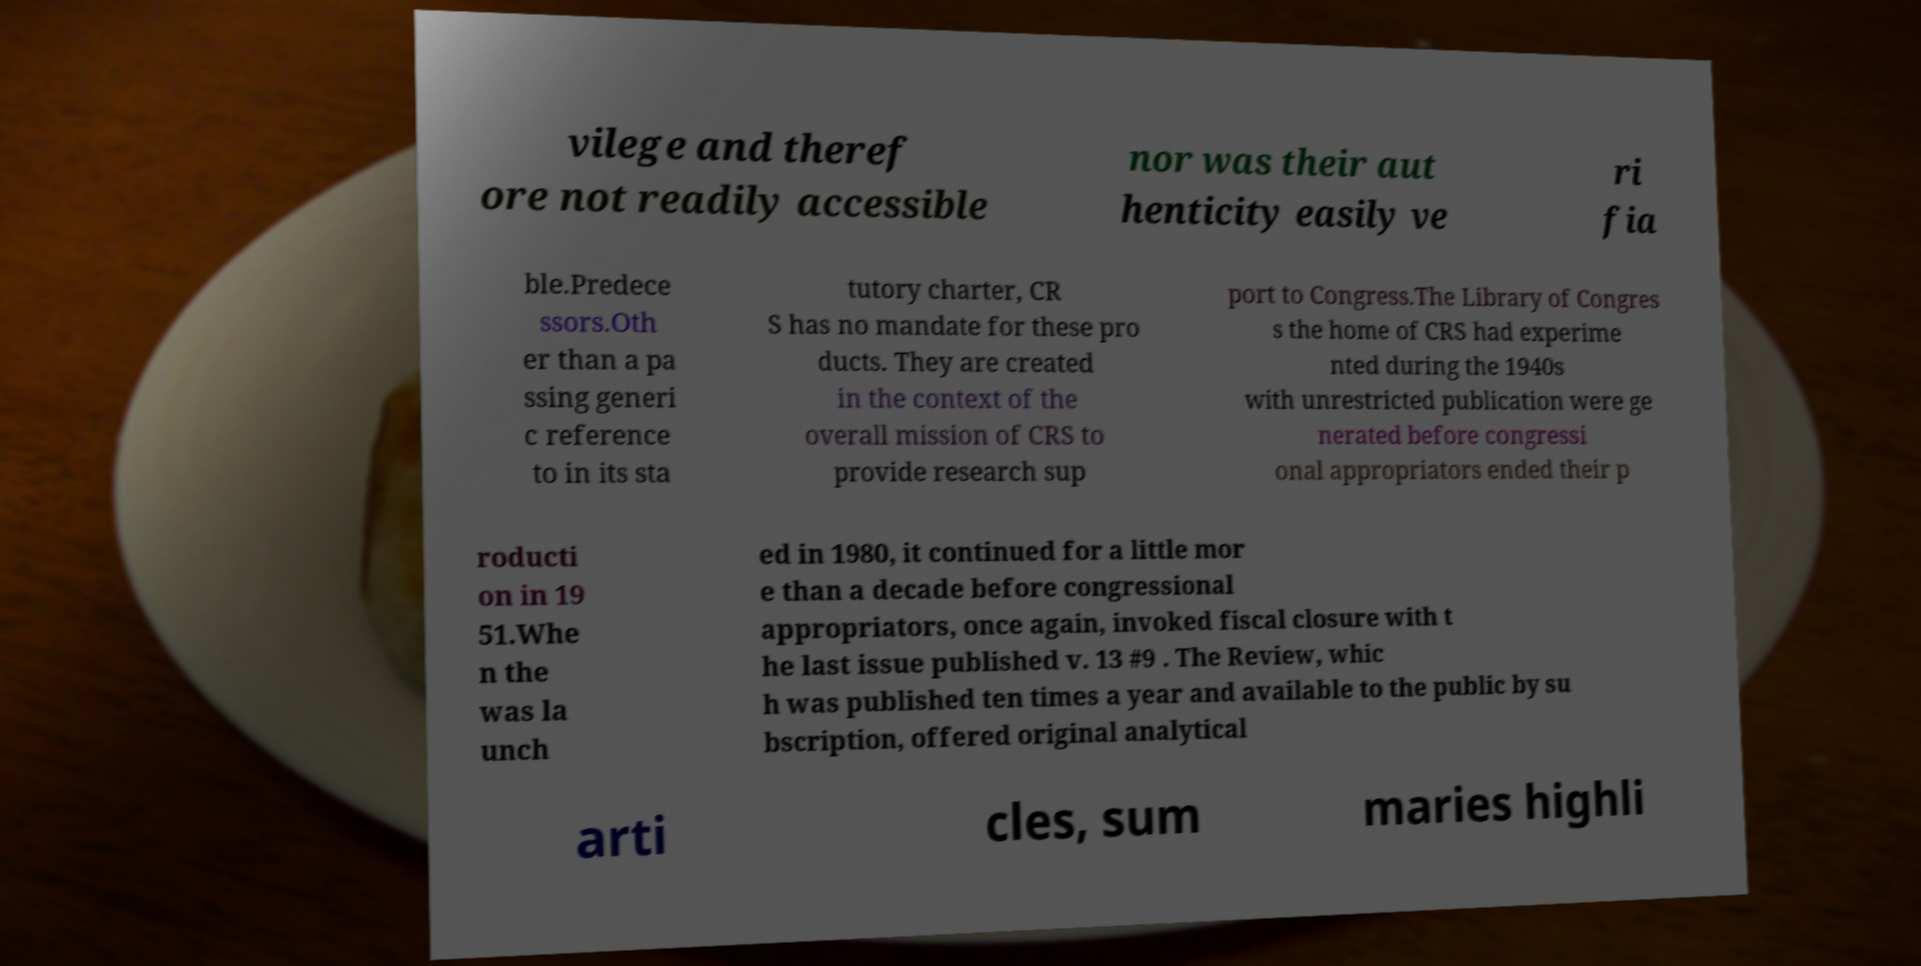What messages or text are displayed in this image? I need them in a readable, typed format. vilege and theref ore not readily accessible nor was their aut henticity easily ve ri fia ble.Predece ssors.Oth er than a pa ssing generi c reference to in its sta tutory charter, CR S has no mandate for these pro ducts. They are created in the context of the overall mission of CRS to provide research sup port to Congress.The Library of Congres s the home of CRS had experime nted during the 1940s with unrestricted publication were ge nerated before congressi onal appropriators ended their p roducti on in 19 51.Whe n the was la unch ed in 1980, it continued for a little mor e than a decade before congressional appropriators, once again, invoked fiscal closure with t he last issue published v. 13 #9 . The Review, whic h was published ten times a year and available to the public by su bscription, offered original analytical arti cles, sum maries highli 